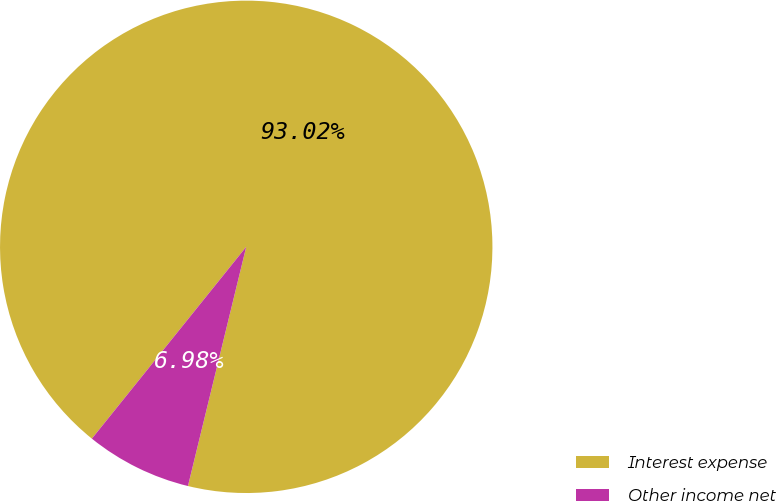Convert chart. <chart><loc_0><loc_0><loc_500><loc_500><pie_chart><fcel>Interest expense<fcel>Other income net<nl><fcel>93.02%<fcel>6.98%<nl></chart> 